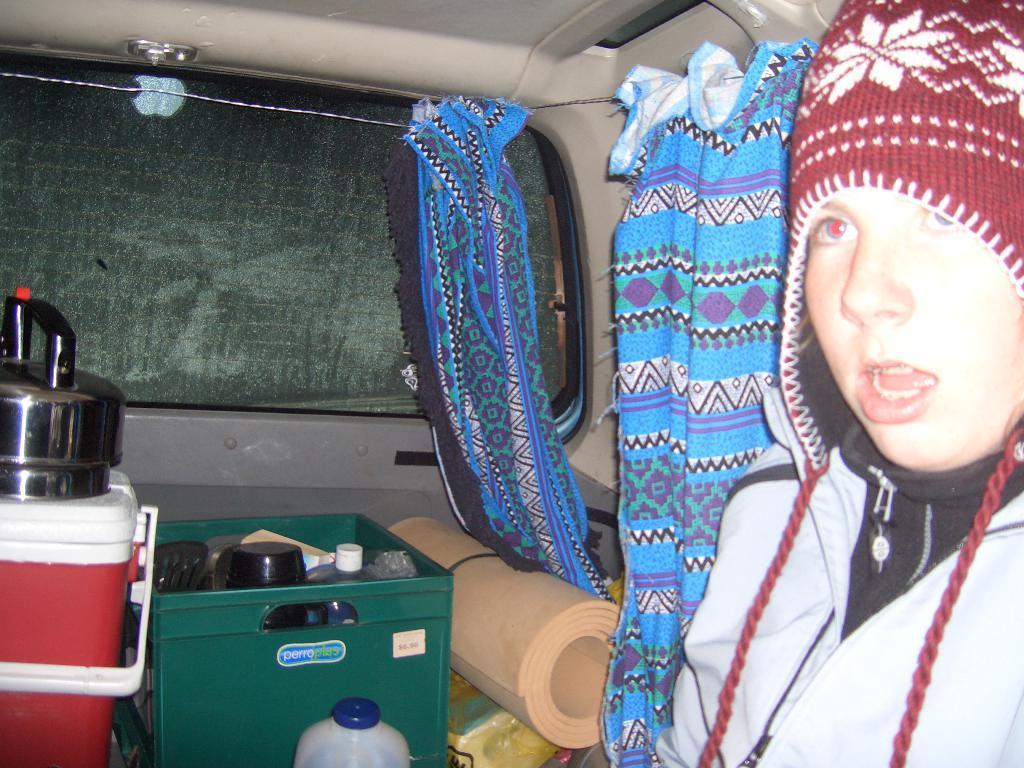Please provide a concise description of this image. In this picture there is a girl who is wearing cap and jacket. She is sitting inside the van. On the left I can see the green box, mat, red box and other objects. In the center I can see the clothes which are placed near to the window. 